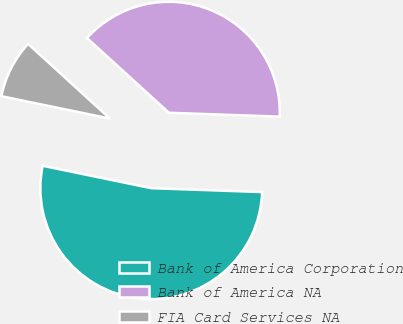Convert chart. <chart><loc_0><loc_0><loc_500><loc_500><pie_chart><fcel>Bank of America Corporation<fcel>Bank of America NA<fcel>FIA Card Services NA<nl><fcel>52.67%<fcel>38.79%<fcel>8.53%<nl></chart> 